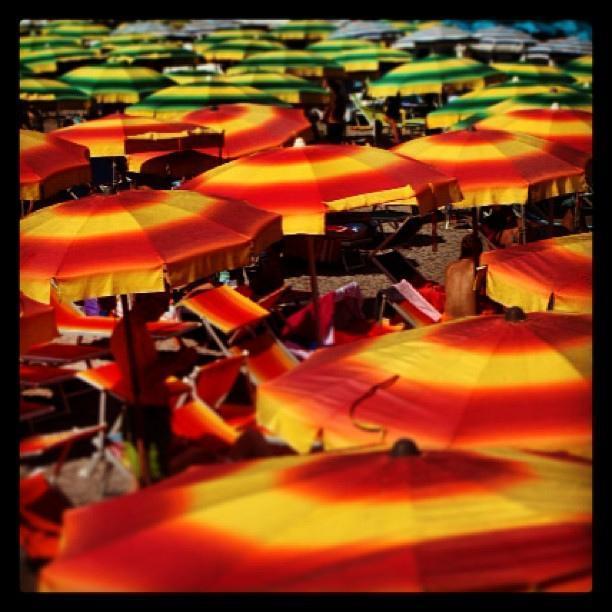How many umbrellas can you see?
Give a very brief answer. 13. How many chairs are visible?
Give a very brief answer. 4. How many people are in the picture?
Give a very brief answer. 2. How many bears are in the picture?
Give a very brief answer. 0. 